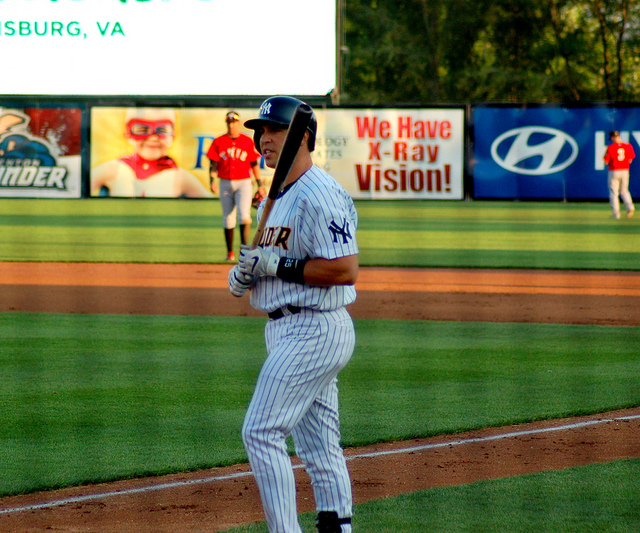Identify and read out the text in this image. We Have Vision! VA SBURG X-Ray P nder 